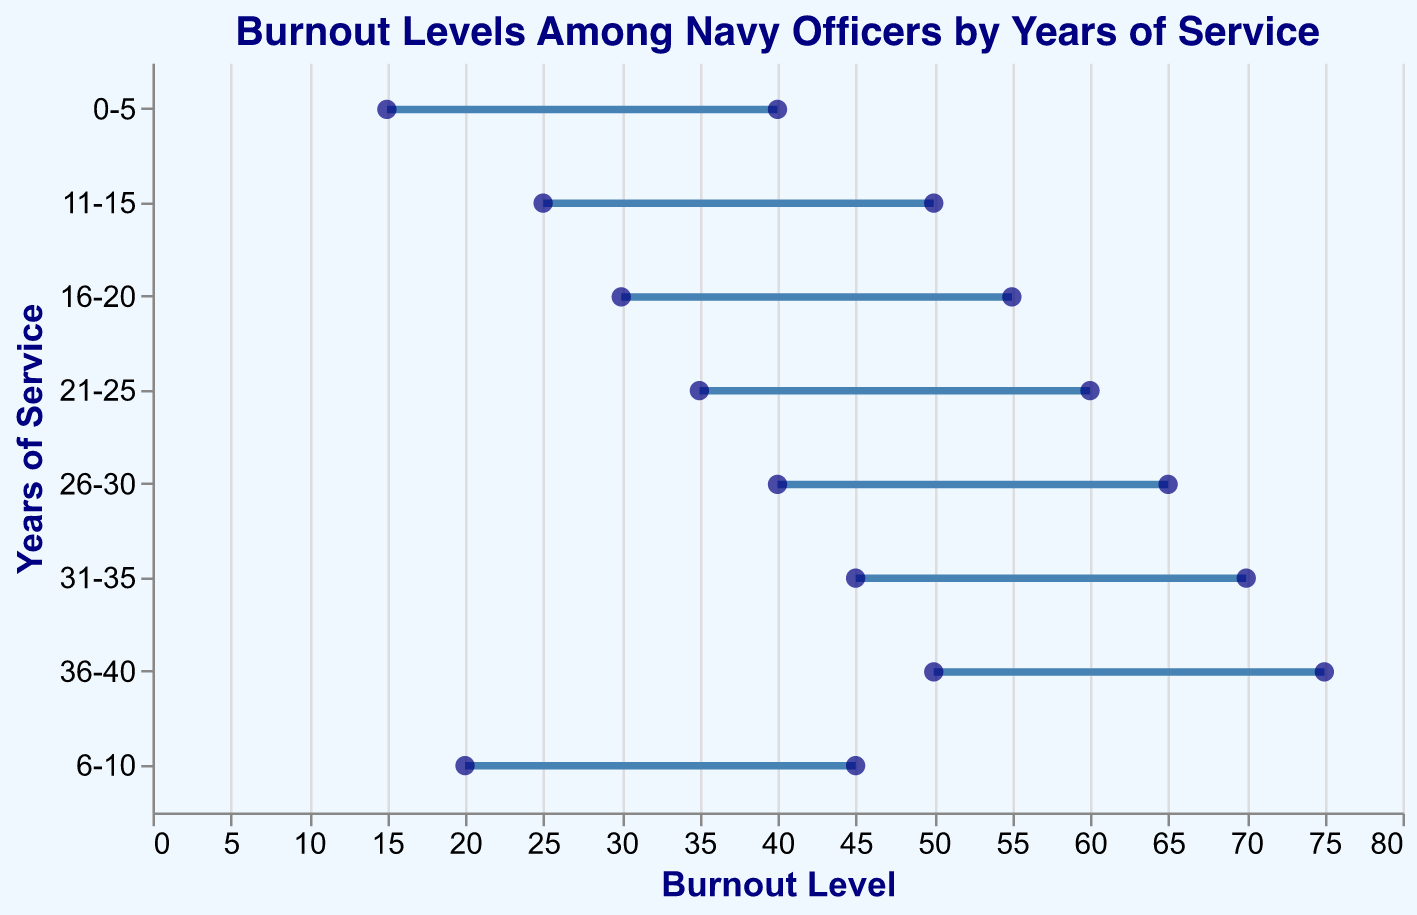What is the title of the plot? The title is displayed at the top of the plot in a large font. It reads "Burnout Levels Among Navy Officers by Years of Service".
Answer: Burnout Levels Among Navy Officers by Years of Service How many different ranges of years of service are shown on the y-axis? The y-axis displays different bands for years of service. Counting them, we get eight ranges: 0-5, 6-10, 11-15, 16-20, 21-25, 26-30, 31-35, and 36-40.
Answer: 8 Between which years of service do we observe the lowest maximum burnout level? The maximum burnout level is represented by the dots on the right side of the ranged dot plots. The lowest maximum burnout level is located at 40, which is seen between 0-5 years of service.
Answer: 0-5 How much does the minimum burnout level increase from the 0-5 years range to the 36-40 years range? The minimum burnout level for 0-5 years is 15, and for 36-40 years it is 50. The increase is calculated by subtracting 15 from 50.
Answer: 35 For which years of service range is the difference between the minimum and the maximum burnout levels the greatest? The difference is calculated by subtracting the minimum burnout level from the maximum burnout level for each range. The greatest difference is 25, observed in the 0-5 years, 6-10 years, 11-15 years, 16-20 years, 21-25 years, 26-30 years, 31-35 years, and 36-40 years ranges, respectively.
Answer: All ranges How does the burnout level change as years of service increase? By examining the plot, it is clear that both the minimum and maximum burnout levels increase as the years of service increase, showing a steady upward trend.
Answer: Increase Which years of service range has a minimum burnout level of 40? The dots on the left side of the ranged dot plot representing the minimum burnout levels should be observed. The minimum burnout level of 40 is in the 26-30 years range.
Answer: 26-30 What is the range of burnout levels for officers with 21-25 years of service? The range is observed by looking at the burnout level minimum and maximum for 21-25 years of service, which are 35 and 60.
Answer: 35 to 60 At what range of years of service does the burnout level first reach a minimum of 30? By identifying the first occurrence of a minimum burnout level of 30, it is observed at the 16-20 years range.
Answer: 16-20 